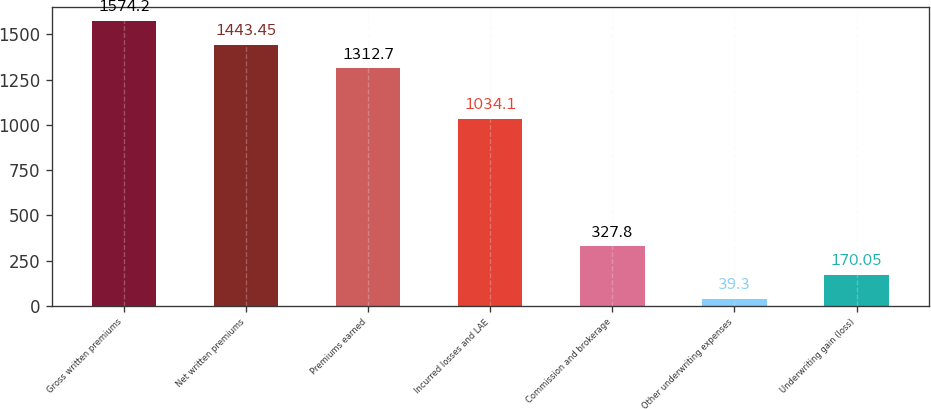Convert chart. <chart><loc_0><loc_0><loc_500><loc_500><bar_chart><fcel>Gross written premiums<fcel>Net written premiums<fcel>Premiums earned<fcel>Incurred losses and LAE<fcel>Commission and brokerage<fcel>Other underwriting expenses<fcel>Underwriting gain (loss)<nl><fcel>1574.2<fcel>1443.45<fcel>1312.7<fcel>1034.1<fcel>327.8<fcel>39.3<fcel>170.05<nl></chart> 